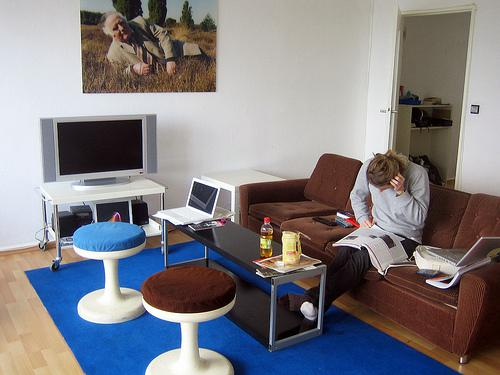Question: where is the person sitting?
Choices:
A. A bench.
B. The ground.
C. Couch.
D. A recliner.
Answer with the letter. Answer: C Question: how many televisions are in the picture?
Choices:
A. One.
B. Zero.
C. Four.
D. Two.
Answer with the letter. Answer: A Question: where is this taking place?
Choices:
A. In a bathroom.
B. In the park.
C. In a living room.
D. By the ocean.
Answer with the letter. Answer: C Question: what kind of room is this?
Choices:
A. Bedroom.
B. Bathroom.
C. Living room.
D. Sitting Room.
Answer with the letter. Answer: C 